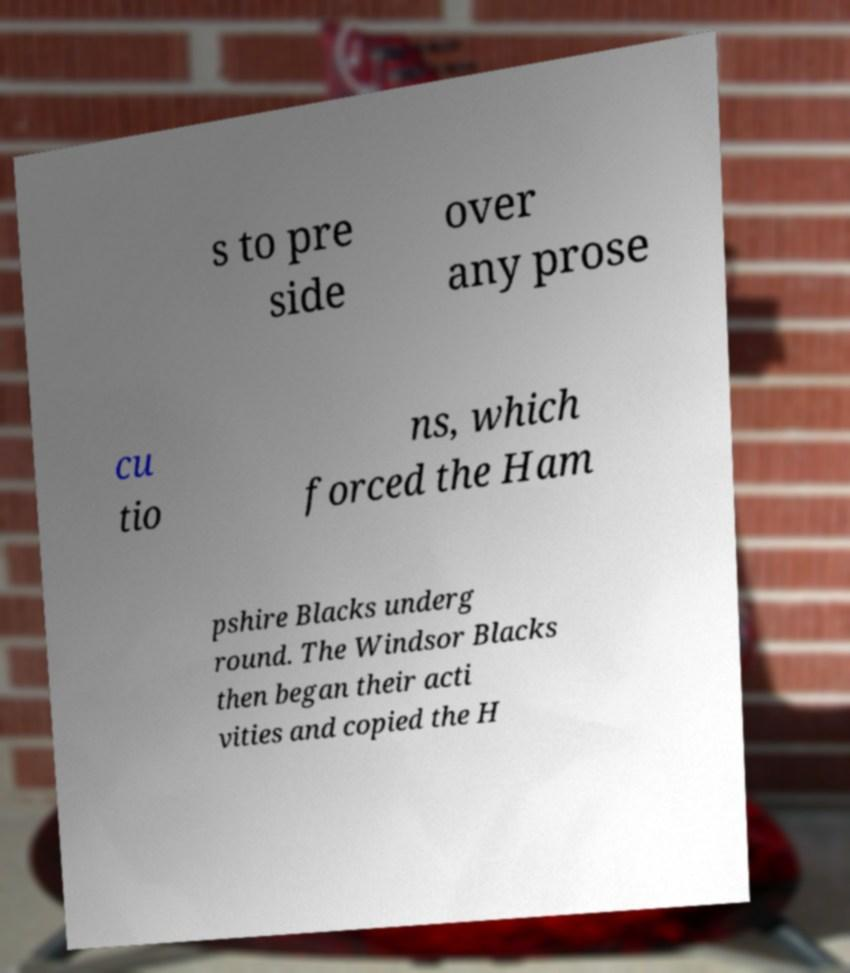Could you assist in decoding the text presented in this image and type it out clearly? s to pre side over any prose cu tio ns, which forced the Ham pshire Blacks underg round. The Windsor Blacks then began their acti vities and copied the H 